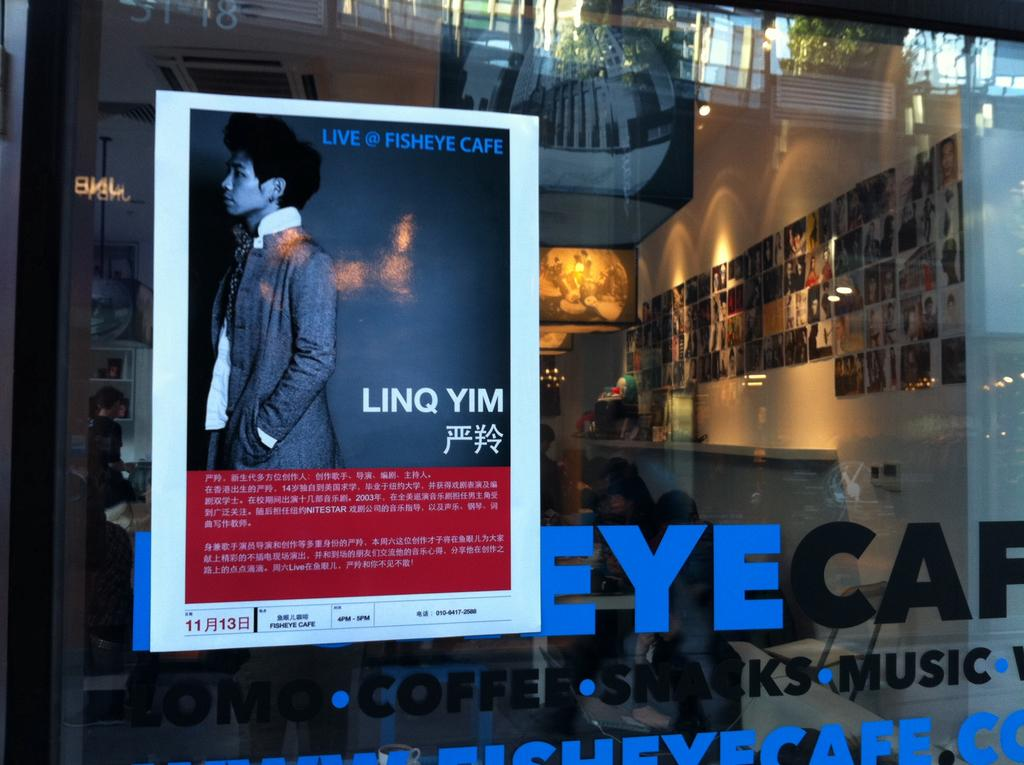<image>
Render a clear and concise summary of the photo. A poster in a window promoting Linq Yim. 